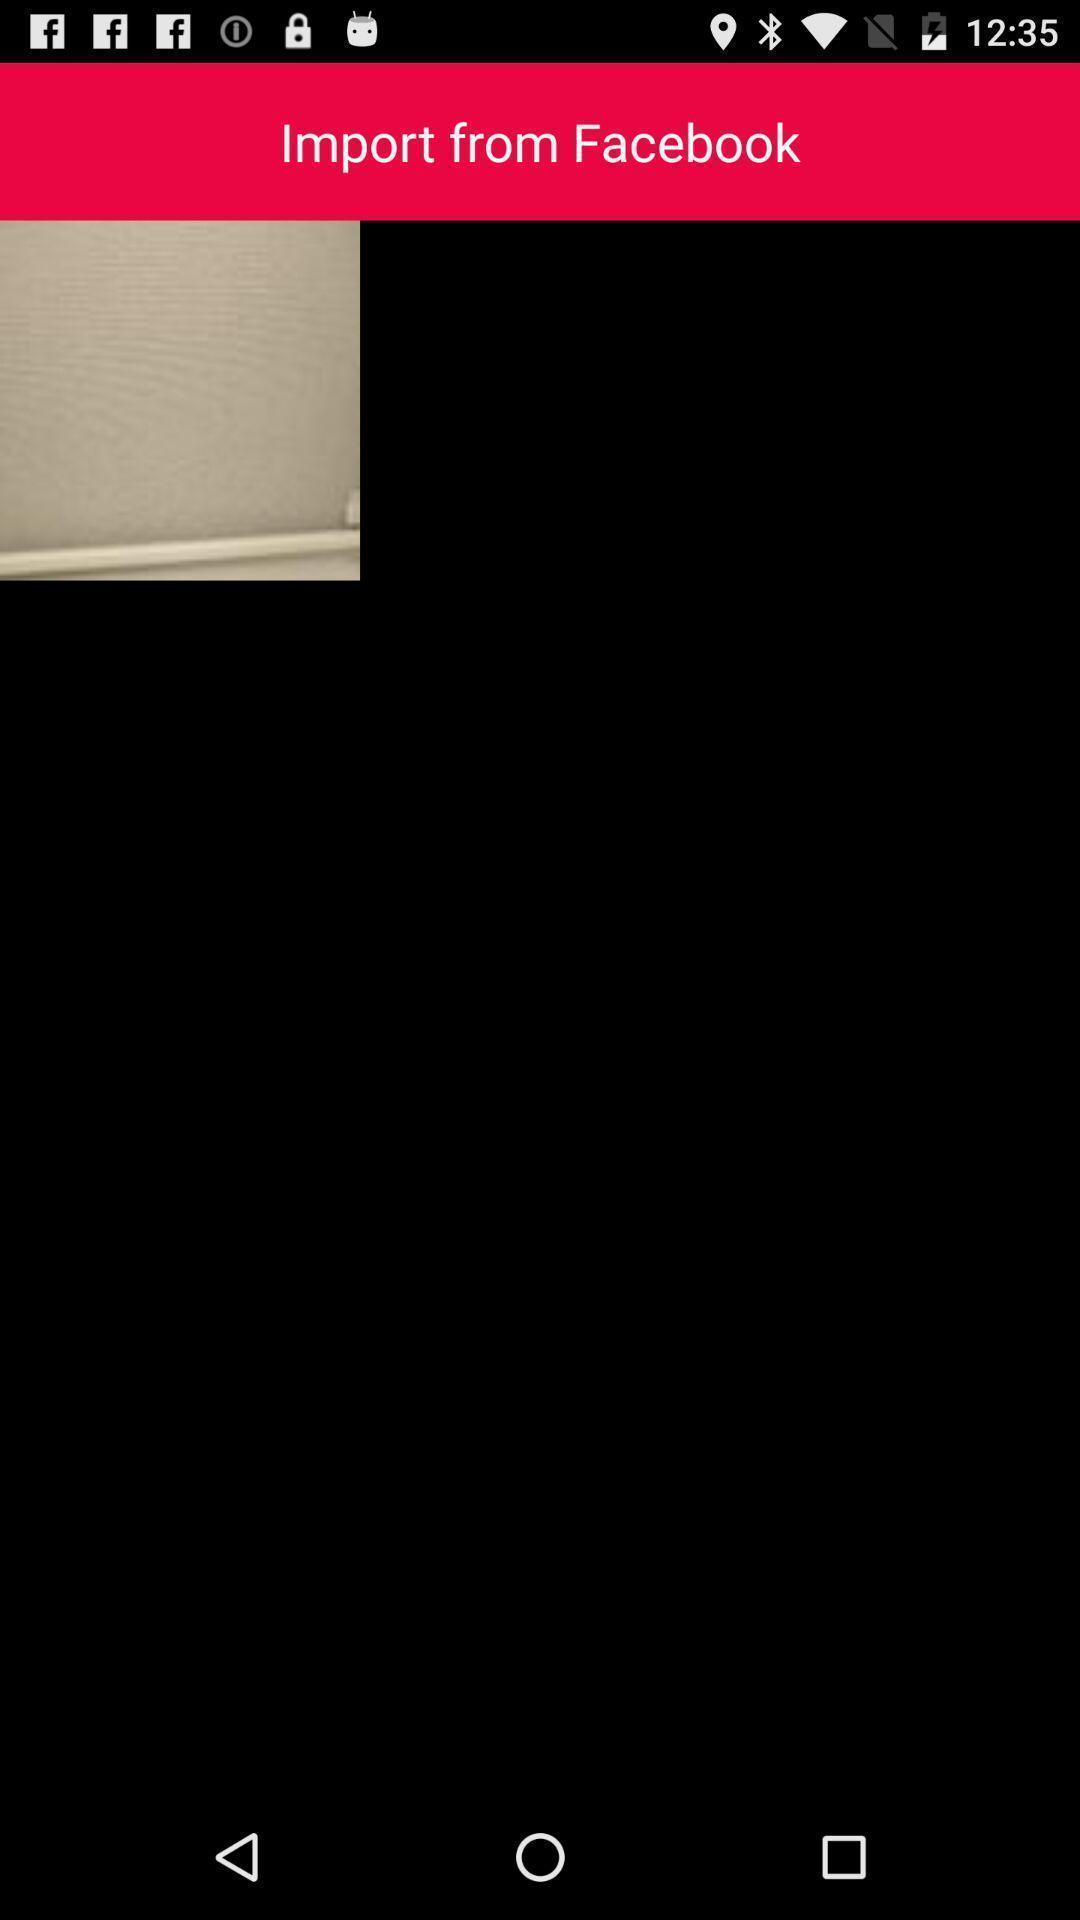Please provide a description for this image. Page that displays an image to import from social application. 